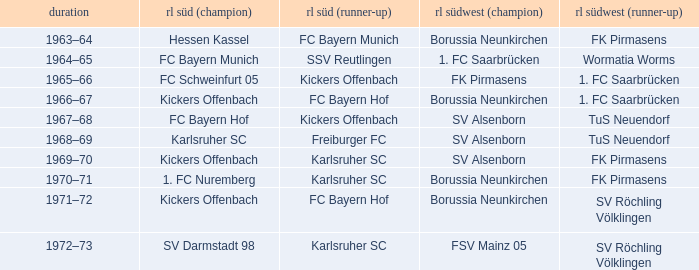Who was rl süd (1st) during the time fk pirmasens was rl südwest (1st)? FC Schweinfurt 05. 